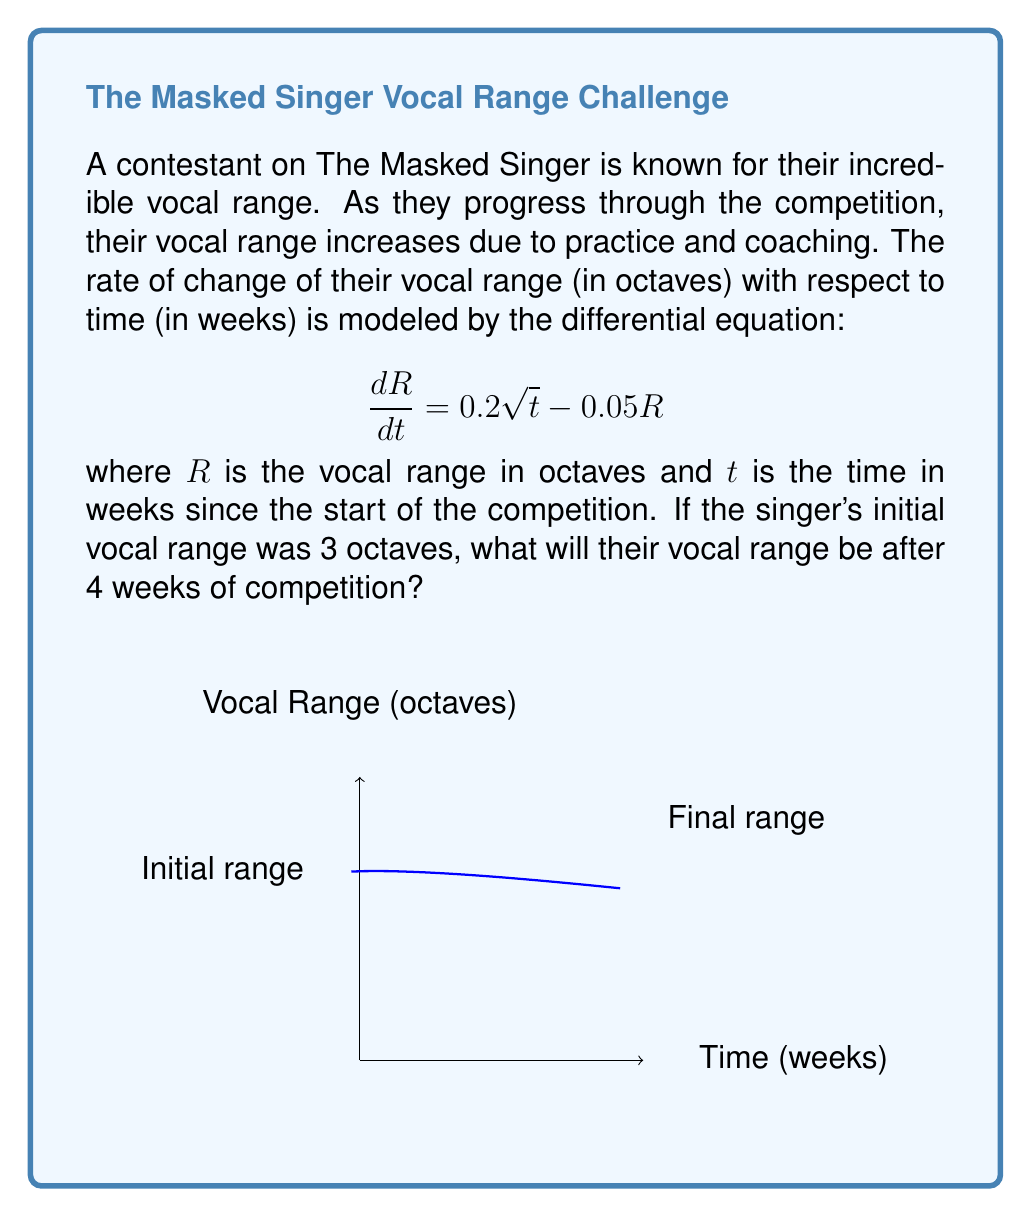Provide a solution to this math problem. Let's solve this step-by-step:

1) The given differential equation is:

   $$\frac{dR}{dt} = 0.2 \sqrt{t} - 0.05R$$

2) This is a linear first-order differential equation. We can solve it using the integrating factor method.

3) The integrating factor is $e^{\int 0.05 dt} = e^{0.05t}$.

4) Multiplying both sides of the equation by the integrating factor:

   $$e^{0.05t} \frac{dR}{dt} + 0.05e^{0.05t}R = 0.2e^{0.05t}\sqrt{t}$$

5) The left side is now the derivative of $e^{0.05t}R$, so we can write:

   $$\frac{d}{dt}(e^{0.05t}R) = 0.2e^{0.05t}\sqrt{t}$$

6) Integrating both sides:

   $$e^{0.05t}R = 0.2 \int e^{0.05t}\sqrt{t} dt = 0.2e^{0.05t}(\frac{2\sqrt{t}}{0.05} - \frac{4}{0.05^{3/2}}) + C$$

7) Solving for $R$:

   $$R = 4 - \frac{4}{0.05^{3/2}}e^{-0.05t} + Ce^{-0.05t}$$

8) Using the initial condition $R(0) = 3$, we can find $C$:

   $$3 = 4 - \frac{4}{0.05^{3/2}} + C$$
   $$C = 3 - 4 + \frac{4}{0.05^{3/2}} = -1 + \frac{4}{0.05^{3/2}}$$

9) Substituting this back into our solution:

   $$R = 4 - (1 + \frac{0.2t^{3/2}}{3})e^{-0.05t}$$

10) Now we can calculate $R(4)$:

    $$R(4) = 4 - (1 + \frac{0.2(4)^{3/2}}{3})e^{-0.05(4)} \approx 3.74$$

Therefore, after 4 weeks, the singer's vocal range will be approximately 3.74 octaves.
Answer: 3.74 octaves 